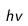<formula> <loc_0><loc_0><loc_500><loc_500>h v</formula> 